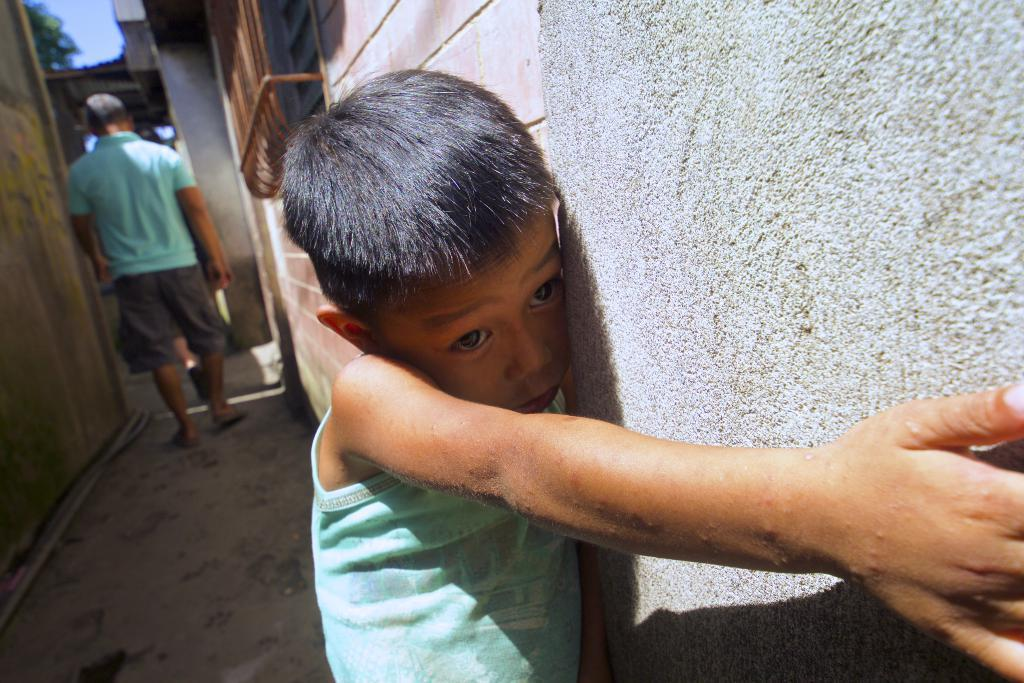Who is present in the image? There is a boy in the image. What can be seen in the background of the image? The sky is visible in the background of the image. What is the man in the image doing? The man is walking in the image. Where is the man walking? The man is walking on a path. What architectural features can be seen in the image? There are walls visible in the image. What type of sticks can be seen in the image? There are no sticks present in the image. Can you tell me how the plane is used in the image? There is no plane present in the image. 